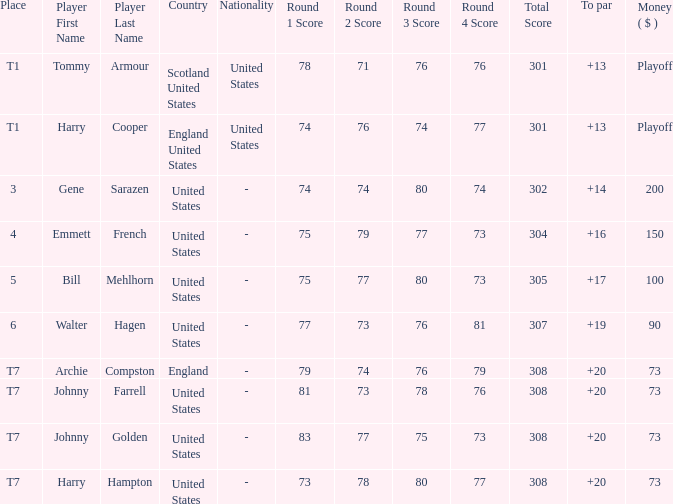What is the ranking when Archie Compston is the player and the money is $73? T7. 